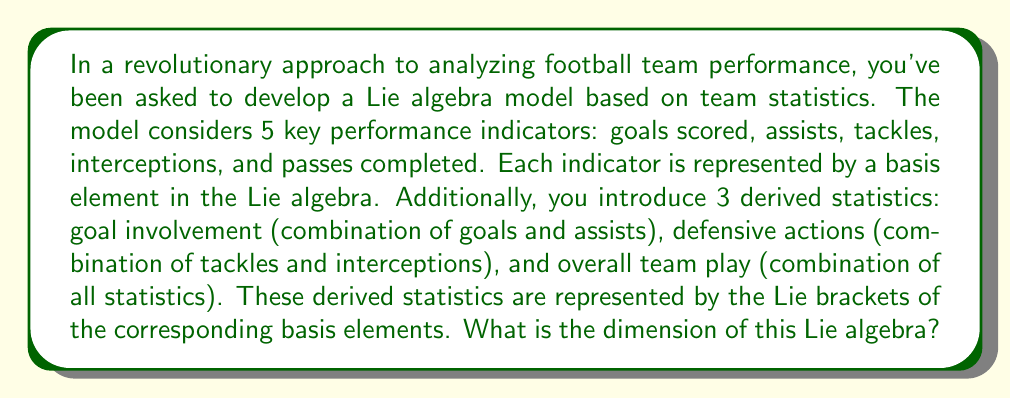Can you solve this math problem? To determine the dimension of this Lie algebra, we need to consider both the basis elements and the independent Lie brackets:

1. Basis elements:
   We have 5 basis elements representing the key performance indicators:
   $e_1$ (goals), $e_2$ (assists), $e_3$ (tackles), $e_4$ (interceptions), $e_5$ (passes)

2. Lie brackets:
   We have 3 derived statistics represented by Lie brackets:
   - Goal involvement: $[e_1, e_2]$
   - Defensive actions: $[e_3, e_4]$
   - Overall team play: This could be represented by multiple brackets, but we'll consider it as one independent element for simplicity.

3. Counting independent elements:
   - 5 basis elements
   - 3 independent Lie brackets

The dimension of a Lie algebra is the number of linearly independent elements in its basis. In this case, we have the original basis elements plus the independent Lie brackets.

Therefore, the dimension of the Lie algebra is: 5 (basis elements) + 3 (independent Lie brackets) = 8.

This 8-dimensional Lie algebra allows for a comprehensive analysis of team performance, combining both individual statistics and their interactions, reminiscent of how a well-coordinated team is more than just the sum of its parts.
Answer: The dimension of the Lie algebra is 8. 